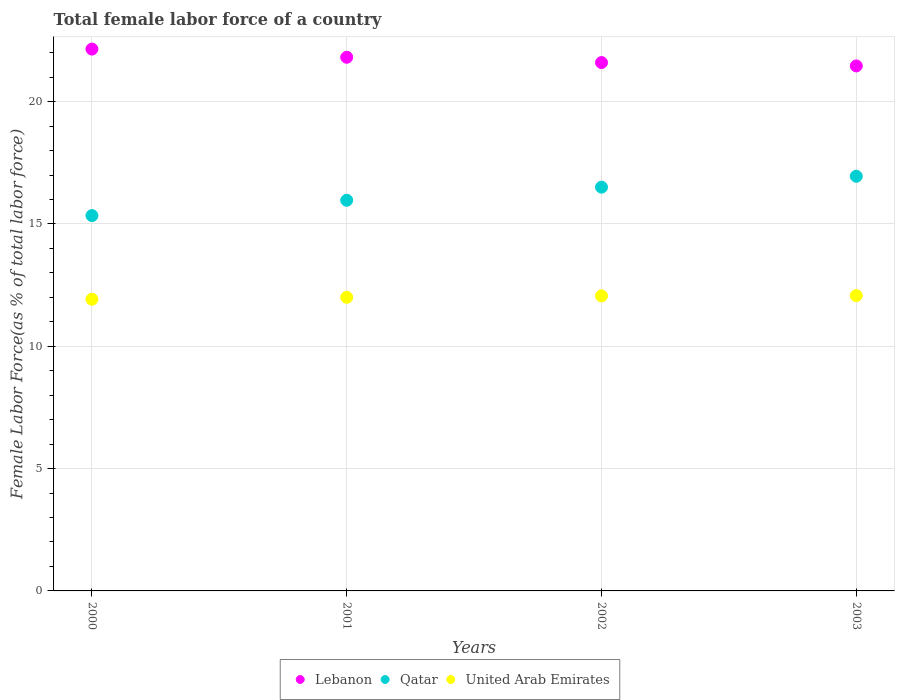How many different coloured dotlines are there?
Offer a terse response. 3. Is the number of dotlines equal to the number of legend labels?
Provide a short and direct response. Yes. What is the percentage of female labor force in United Arab Emirates in 2002?
Offer a terse response. 12.06. Across all years, what is the maximum percentage of female labor force in Lebanon?
Provide a short and direct response. 22.15. Across all years, what is the minimum percentage of female labor force in Qatar?
Give a very brief answer. 15.34. What is the total percentage of female labor force in Lebanon in the graph?
Make the answer very short. 87.02. What is the difference between the percentage of female labor force in United Arab Emirates in 2000 and that in 2002?
Make the answer very short. -0.14. What is the difference between the percentage of female labor force in Lebanon in 2002 and the percentage of female labor force in Qatar in 2000?
Keep it short and to the point. 6.25. What is the average percentage of female labor force in Lebanon per year?
Make the answer very short. 21.76. In the year 2001, what is the difference between the percentage of female labor force in Qatar and percentage of female labor force in Lebanon?
Keep it short and to the point. -5.85. In how many years, is the percentage of female labor force in Qatar greater than 3 %?
Give a very brief answer. 4. What is the ratio of the percentage of female labor force in Qatar in 2000 to that in 2003?
Your answer should be compact. 0.91. Is the percentage of female labor force in Lebanon in 2001 less than that in 2003?
Ensure brevity in your answer.  No. Is the difference between the percentage of female labor force in Qatar in 2001 and 2003 greater than the difference between the percentage of female labor force in Lebanon in 2001 and 2003?
Offer a very short reply. No. What is the difference between the highest and the second highest percentage of female labor force in Qatar?
Offer a terse response. 0.45. What is the difference between the highest and the lowest percentage of female labor force in Lebanon?
Make the answer very short. 0.69. In how many years, is the percentage of female labor force in Lebanon greater than the average percentage of female labor force in Lebanon taken over all years?
Offer a terse response. 2. Is the sum of the percentage of female labor force in Lebanon in 2000 and 2003 greater than the maximum percentage of female labor force in United Arab Emirates across all years?
Your response must be concise. Yes. Is the percentage of female labor force in United Arab Emirates strictly greater than the percentage of female labor force in Lebanon over the years?
Provide a short and direct response. No. Is the percentage of female labor force in Lebanon strictly less than the percentage of female labor force in Qatar over the years?
Ensure brevity in your answer.  No. Does the graph contain any zero values?
Provide a succinct answer. No. Does the graph contain grids?
Make the answer very short. Yes. What is the title of the graph?
Offer a terse response. Total female labor force of a country. What is the label or title of the Y-axis?
Provide a succinct answer. Female Labor Force(as % of total labor force). What is the Female Labor Force(as % of total labor force) in Lebanon in 2000?
Offer a terse response. 22.15. What is the Female Labor Force(as % of total labor force) in Qatar in 2000?
Your answer should be very brief. 15.34. What is the Female Labor Force(as % of total labor force) of United Arab Emirates in 2000?
Your answer should be compact. 11.92. What is the Female Labor Force(as % of total labor force) of Lebanon in 2001?
Your answer should be very brief. 21.82. What is the Female Labor Force(as % of total labor force) of Qatar in 2001?
Offer a terse response. 15.97. What is the Female Labor Force(as % of total labor force) in United Arab Emirates in 2001?
Offer a very short reply. 12. What is the Female Labor Force(as % of total labor force) of Lebanon in 2002?
Offer a terse response. 21.6. What is the Female Labor Force(as % of total labor force) in Qatar in 2002?
Ensure brevity in your answer.  16.5. What is the Female Labor Force(as % of total labor force) in United Arab Emirates in 2002?
Your answer should be compact. 12.06. What is the Female Labor Force(as % of total labor force) of Lebanon in 2003?
Provide a short and direct response. 21.46. What is the Female Labor Force(as % of total labor force) of Qatar in 2003?
Your answer should be compact. 16.95. What is the Female Labor Force(as % of total labor force) in United Arab Emirates in 2003?
Your answer should be compact. 12.07. Across all years, what is the maximum Female Labor Force(as % of total labor force) in Lebanon?
Your answer should be very brief. 22.15. Across all years, what is the maximum Female Labor Force(as % of total labor force) of Qatar?
Give a very brief answer. 16.95. Across all years, what is the maximum Female Labor Force(as % of total labor force) in United Arab Emirates?
Your answer should be compact. 12.07. Across all years, what is the minimum Female Labor Force(as % of total labor force) of Lebanon?
Offer a very short reply. 21.46. Across all years, what is the minimum Female Labor Force(as % of total labor force) in Qatar?
Provide a succinct answer. 15.34. Across all years, what is the minimum Female Labor Force(as % of total labor force) of United Arab Emirates?
Offer a very short reply. 11.92. What is the total Female Labor Force(as % of total labor force) of Lebanon in the graph?
Your answer should be very brief. 87.02. What is the total Female Labor Force(as % of total labor force) in Qatar in the graph?
Your answer should be compact. 64.77. What is the total Female Labor Force(as % of total labor force) in United Arab Emirates in the graph?
Provide a short and direct response. 48.06. What is the difference between the Female Labor Force(as % of total labor force) of Lebanon in 2000 and that in 2001?
Keep it short and to the point. 0.33. What is the difference between the Female Labor Force(as % of total labor force) in Qatar in 2000 and that in 2001?
Offer a terse response. -0.63. What is the difference between the Female Labor Force(as % of total labor force) in United Arab Emirates in 2000 and that in 2001?
Ensure brevity in your answer.  -0.08. What is the difference between the Female Labor Force(as % of total labor force) in Lebanon in 2000 and that in 2002?
Your answer should be very brief. 0.55. What is the difference between the Female Labor Force(as % of total labor force) of Qatar in 2000 and that in 2002?
Provide a short and direct response. -1.16. What is the difference between the Female Labor Force(as % of total labor force) in United Arab Emirates in 2000 and that in 2002?
Your response must be concise. -0.14. What is the difference between the Female Labor Force(as % of total labor force) in Lebanon in 2000 and that in 2003?
Ensure brevity in your answer.  0.69. What is the difference between the Female Labor Force(as % of total labor force) of Qatar in 2000 and that in 2003?
Ensure brevity in your answer.  -1.61. What is the difference between the Female Labor Force(as % of total labor force) of Lebanon in 2001 and that in 2002?
Your answer should be very brief. 0.22. What is the difference between the Female Labor Force(as % of total labor force) in Qatar in 2001 and that in 2002?
Provide a short and direct response. -0.54. What is the difference between the Female Labor Force(as % of total labor force) of United Arab Emirates in 2001 and that in 2002?
Provide a short and direct response. -0.06. What is the difference between the Female Labor Force(as % of total labor force) of Lebanon in 2001 and that in 2003?
Offer a very short reply. 0.35. What is the difference between the Female Labor Force(as % of total labor force) in Qatar in 2001 and that in 2003?
Your response must be concise. -0.98. What is the difference between the Female Labor Force(as % of total labor force) of United Arab Emirates in 2001 and that in 2003?
Your response must be concise. -0.07. What is the difference between the Female Labor Force(as % of total labor force) of Lebanon in 2002 and that in 2003?
Give a very brief answer. 0.14. What is the difference between the Female Labor Force(as % of total labor force) of Qatar in 2002 and that in 2003?
Provide a short and direct response. -0.45. What is the difference between the Female Labor Force(as % of total labor force) of United Arab Emirates in 2002 and that in 2003?
Provide a succinct answer. -0.01. What is the difference between the Female Labor Force(as % of total labor force) in Lebanon in 2000 and the Female Labor Force(as % of total labor force) in Qatar in 2001?
Give a very brief answer. 6.18. What is the difference between the Female Labor Force(as % of total labor force) of Lebanon in 2000 and the Female Labor Force(as % of total labor force) of United Arab Emirates in 2001?
Make the answer very short. 10.15. What is the difference between the Female Labor Force(as % of total labor force) of Qatar in 2000 and the Female Labor Force(as % of total labor force) of United Arab Emirates in 2001?
Provide a succinct answer. 3.34. What is the difference between the Female Labor Force(as % of total labor force) in Lebanon in 2000 and the Female Labor Force(as % of total labor force) in Qatar in 2002?
Provide a short and direct response. 5.64. What is the difference between the Female Labor Force(as % of total labor force) of Lebanon in 2000 and the Female Labor Force(as % of total labor force) of United Arab Emirates in 2002?
Your answer should be compact. 10.09. What is the difference between the Female Labor Force(as % of total labor force) of Qatar in 2000 and the Female Labor Force(as % of total labor force) of United Arab Emirates in 2002?
Make the answer very short. 3.28. What is the difference between the Female Labor Force(as % of total labor force) of Lebanon in 2000 and the Female Labor Force(as % of total labor force) of Qatar in 2003?
Your answer should be compact. 5.2. What is the difference between the Female Labor Force(as % of total labor force) in Lebanon in 2000 and the Female Labor Force(as % of total labor force) in United Arab Emirates in 2003?
Give a very brief answer. 10.08. What is the difference between the Female Labor Force(as % of total labor force) in Qatar in 2000 and the Female Labor Force(as % of total labor force) in United Arab Emirates in 2003?
Provide a succinct answer. 3.27. What is the difference between the Female Labor Force(as % of total labor force) of Lebanon in 2001 and the Female Labor Force(as % of total labor force) of Qatar in 2002?
Your answer should be very brief. 5.31. What is the difference between the Female Labor Force(as % of total labor force) of Lebanon in 2001 and the Female Labor Force(as % of total labor force) of United Arab Emirates in 2002?
Keep it short and to the point. 9.75. What is the difference between the Female Labor Force(as % of total labor force) in Qatar in 2001 and the Female Labor Force(as % of total labor force) in United Arab Emirates in 2002?
Provide a short and direct response. 3.91. What is the difference between the Female Labor Force(as % of total labor force) in Lebanon in 2001 and the Female Labor Force(as % of total labor force) in Qatar in 2003?
Your response must be concise. 4.86. What is the difference between the Female Labor Force(as % of total labor force) in Lebanon in 2001 and the Female Labor Force(as % of total labor force) in United Arab Emirates in 2003?
Make the answer very short. 9.74. What is the difference between the Female Labor Force(as % of total labor force) in Qatar in 2001 and the Female Labor Force(as % of total labor force) in United Arab Emirates in 2003?
Make the answer very short. 3.9. What is the difference between the Female Labor Force(as % of total labor force) in Lebanon in 2002 and the Female Labor Force(as % of total labor force) in Qatar in 2003?
Keep it short and to the point. 4.65. What is the difference between the Female Labor Force(as % of total labor force) of Lebanon in 2002 and the Female Labor Force(as % of total labor force) of United Arab Emirates in 2003?
Provide a succinct answer. 9.52. What is the difference between the Female Labor Force(as % of total labor force) in Qatar in 2002 and the Female Labor Force(as % of total labor force) in United Arab Emirates in 2003?
Provide a short and direct response. 4.43. What is the average Female Labor Force(as % of total labor force) of Lebanon per year?
Provide a short and direct response. 21.76. What is the average Female Labor Force(as % of total labor force) in Qatar per year?
Provide a short and direct response. 16.19. What is the average Female Labor Force(as % of total labor force) of United Arab Emirates per year?
Provide a succinct answer. 12.02. In the year 2000, what is the difference between the Female Labor Force(as % of total labor force) of Lebanon and Female Labor Force(as % of total labor force) of Qatar?
Make the answer very short. 6.81. In the year 2000, what is the difference between the Female Labor Force(as % of total labor force) of Lebanon and Female Labor Force(as % of total labor force) of United Arab Emirates?
Your response must be concise. 10.23. In the year 2000, what is the difference between the Female Labor Force(as % of total labor force) of Qatar and Female Labor Force(as % of total labor force) of United Arab Emirates?
Your answer should be compact. 3.42. In the year 2001, what is the difference between the Female Labor Force(as % of total labor force) of Lebanon and Female Labor Force(as % of total labor force) of Qatar?
Your response must be concise. 5.85. In the year 2001, what is the difference between the Female Labor Force(as % of total labor force) in Lebanon and Female Labor Force(as % of total labor force) in United Arab Emirates?
Make the answer very short. 9.81. In the year 2001, what is the difference between the Female Labor Force(as % of total labor force) in Qatar and Female Labor Force(as % of total labor force) in United Arab Emirates?
Provide a short and direct response. 3.97. In the year 2002, what is the difference between the Female Labor Force(as % of total labor force) in Lebanon and Female Labor Force(as % of total labor force) in Qatar?
Offer a very short reply. 5.09. In the year 2002, what is the difference between the Female Labor Force(as % of total labor force) in Lebanon and Female Labor Force(as % of total labor force) in United Arab Emirates?
Make the answer very short. 9.54. In the year 2002, what is the difference between the Female Labor Force(as % of total labor force) in Qatar and Female Labor Force(as % of total labor force) in United Arab Emirates?
Ensure brevity in your answer.  4.44. In the year 2003, what is the difference between the Female Labor Force(as % of total labor force) in Lebanon and Female Labor Force(as % of total labor force) in Qatar?
Your answer should be very brief. 4.51. In the year 2003, what is the difference between the Female Labor Force(as % of total labor force) in Lebanon and Female Labor Force(as % of total labor force) in United Arab Emirates?
Ensure brevity in your answer.  9.39. In the year 2003, what is the difference between the Female Labor Force(as % of total labor force) of Qatar and Female Labor Force(as % of total labor force) of United Arab Emirates?
Offer a very short reply. 4.88. What is the ratio of the Female Labor Force(as % of total labor force) of Lebanon in 2000 to that in 2001?
Your answer should be compact. 1.02. What is the ratio of the Female Labor Force(as % of total labor force) of Qatar in 2000 to that in 2001?
Offer a terse response. 0.96. What is the ratio of the Female Labor Force(as % of total labor force) in Lebanon in 2000 to that in 2002?
Offer a very short reply. 1.03. What is the ratio of the Female Labor Force(as % of total labor force) of Qatar in 2000 to that in 2002?
Offer a terse response. 0.93. What is the ratio of the Female Labor Force(as % of total labor force) of United Arab Emirates in 2000 to that in 2002?
Offer a very short reply. 0.99. What is the ratio of the Female Labor Force(as % of total labor force) of Lebanon in 2000 to that in 2003?
Your answer should be compact. 1.03. What is the ratio of the Female Labor Force(as % of total labor force) in Qatar in 2000 to that in 2003?
Your answer should be very brief. 0.91. What is the ratio of the Female Labor Force(as % of total labor force) in United Arab Emirates in 2000 to that in 2003?
Provide a short and direct response. 0.99. What is the ratio of the Female Labor Force(as % of total labor force) in Qatar in 2001 to that in 2002?
Your answer should be compact. 0.97. What is the ratio of the Female Labor Force(as % of total labor force) of Lebanon in 2001 to that in 2003?
Provide a short and direct response. 1.02. What is the ratio of the Female Labor Force(as % of total labor force) of Qatar in 2001 to that in 2003?
Your answer should be very brief. 0.94. What is the ratio of the Female Labor Force(as % of total labor force) of United Arab Emirates in 2001 to that in 2003?
Make the answer very short. 0.99. What is the ratio of the Female Labor Force(as % of total labor force) in Lebanon in 2002 to that in 2003?
Keep it short and to the point. 1.01. What is the ratio of the Female Labor Force(as % of total labor force) in Qatar in 2002 to that in 2003?
Your answer should be compact. 0.97. What is the ratio of the Female Labor Force(as % of total labor force) in United Arab Emirates in 2002 to that in 2003?
Offer a very short reply. 1. What is the difference between the highest and the second highest Female Labor Force(as % of total labor force) in Lebanon?
Make the answer very short. 0.33. What is the difference between the highest and the second highest Female Labor Force(as % of total labor force) of Qatar?
Provide a short and direct response. 0.45. What is the difference between the highest and the second highest Female Labor Force(as % of total labor force) in United Arab Emirates?
Offer a terse response. 0.01. What is the difference between the highest and the lowest Female Labor Force(as % of total labor force) of Lebanon?
Offer a very short reply. 0.69. What is the difference between the highest and the lowest Female Labor Force(as % of total labor force) of Qatar?
Offer a very short reply. 1.61. 